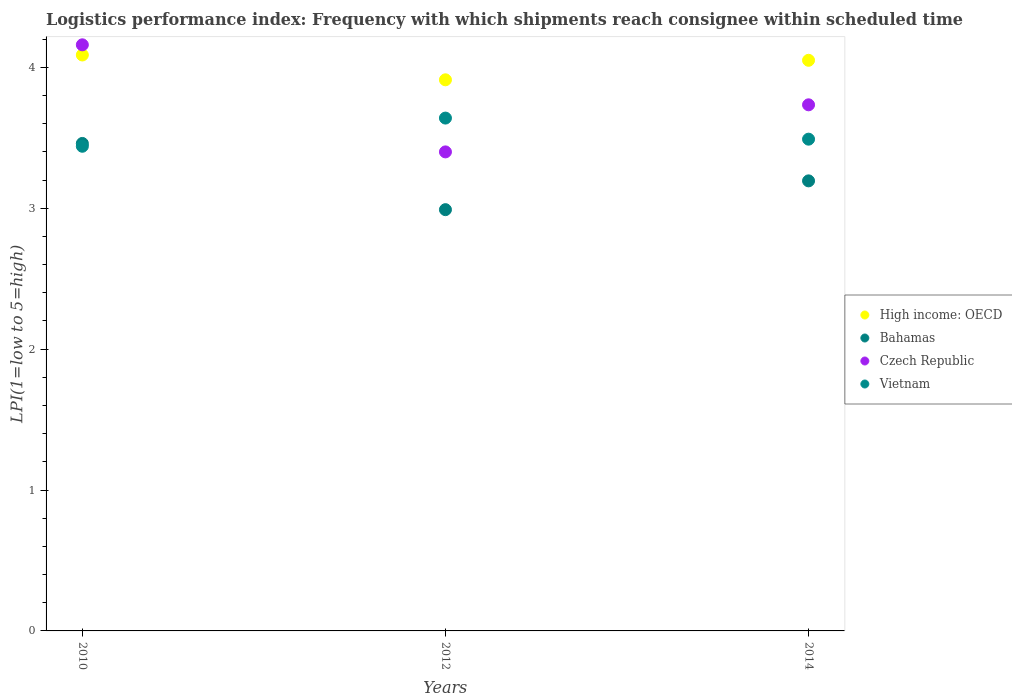Is the number of dotlines equal to the number of legend labels?
Your response must be concise. Yes. What is the logistics performance index in Vietnam in 2014?
Ensure brevity in your answer.  3.49. Across all years, what is the maximum logistics performance index in Bahamas?
Make the answer very short. 3.46. Across all years, what is the minimum logistics performance index in Bahamas?
Your answer should be very brief. 2.99. In which year was the logistics performance index in High income: OECD maximum?
Provide a short and direct response. 2010. In which year was the logistics performance index in Bahamas minimum?
Make the answer very short. 2012. What is the total logistics performance index in Bahamas in the graph?
Provide a succinct answer. 9.64. What is the difference between the logistics performance index in High income: OECD in 2012 and that in 2014?
Your answer should be very brief. -0.14. What is the difference between the logistics performance index in Bahamas in 2012 and the logistics performance index in Czech Republic in 2010?
Your answer should be very brief. -1.17. What is the average logistics performance index in High income: OECD per year?
Make the answer very short. 4.02. In the year 2012, what is the difference between the logistics performance index in High income: OECD and logistics performance index in Bahamas?
Ensure brevity in your answer.  0.92. In how many years, is the logistics performance index in Vietnam greater than 3.6?
Keep it short and to the point. 1. What is the ratio of the logistics performance index in Bahamas in 2010 to that in 2012?
Ensure brevity in your answer.  1.16. What is the difference between the highest and the second highest logistics performance index in Bahamas?
Your answer should be compact. 0.27. What is the difference between the highest and the lowest logistics performance index in Bahamas?
Your response must be concise. 0.47. Is the logistics performance index in Czech Republic strictly greater than the logistics performance index in High income: OECD over the years?
Your response must be concise. No. Is the logistics performance index in Bahamas strictly less than the logistics performance index in High income: OECD over the years?
Your answer should be very brief. Yes. How many dotlines are there?
Ensure brevity in your answer.  4. How many years are there in the graph?
Provide a succinct answer. 3. Where does the legend appear in the graph?
Keep it short and to the point. Center right. How many legend labels are there?
Ensure brevity in your answer.  4. What is the title of the graph?
Keep it short and to the point. Logistics performance index: Frequency with which shipments reach consignee within scheduled time. Does "Thailand" appear as one of the legend labels in the graph?
Your answer should be very brief. No. What is the label or title of the X-axis?
Your answer should be compact. Years. What is the label or title of the Y-axis?
Offer a very short reply. LPI(1=low to 5=high). What is the LPI(1=low to 5=high) in High income: OECD in 2010?
Your answer should be very brief. 4.09. What is the LPI(1=low to 5=high) in Bahamas in 2010?
Provide a succinct answer. 3.46. What is the LPI(1=low to 5=high) of Czech Republic in 2010?
Offer a terse response. 4.16. What is the LPI(1=low to 5=high) of Vietnam in 2010?
Keep it short and to the point. 3.44. What is the LPI(1=low to 5=high) in High income: OECD in 2012?
Make the answer very short. 3.91. What is the LPI(1=low to 5=high) of Bahamas in 2012?
Provide a succinct answer. 2.99. What is the LPI(1=low to 5=high) in Czech Republic in 2012?
Keep it short and to the point. 3.4. What is the LPI(1=low to 5=high) of Vietnam in 2012?
Offer a very short reply. 3.64. What is the LPI(1=low to 5=high) in High income: OECD in 2014?
Make the answer very short. 4.05. What is the LPI(1=low to 5=high) in Bahamas in 2014?
Offer a terse response. 3.19. What is the LPI(1=low to 5=high) in Czech Republic in 2014?
Provide a short and direct response. 3.73. What is the LPI(1=low to 5=high) of Vietnam in 2014?
Offer a very short reply. 3.49. Across all years, what is the maximum LPI(1=low to 5=high) of High income: OECD?
Ensure brevity in your answer.  4.09. Across all years, what is the maximum LPI(1=low to 5=high) in Bahamas?
Keep it short and to the point. 3.46. Across all years, what is the maximum LPI(1=low to 5=high) of Czech Republic?
Provide a short and direct response. 4.16. Across all years, what is the maximum LPI(1=low to 5=high) of Vietnam?
Ensure brevity in your answer.  3.64. Across all years, what is the minimum LPI(1=low to 5=high) in High income: OECD?
Offer a very short reply. 3.91. Across all years, what is the minimum LPI(1=low to 5=high) in Bahamas?
Give a very brief answer. 2.99. Across all years, what is the minimum LPI(1=low to 5=high) of Vietnam?
Offer a very short reply. 3.44. What is the total LPI(1=low to 5=high) of High income: OECD in the graph?
Provide a short and direct response. 12.05. What is the total LPI(1=low to 5=high) in Bahamas in the graph?
Make the answer very short. 9.64. What is the total LPI(1=low to 5=high) in Czech Republic in the graph?
Your answer should be very brief. 11.29. What is the total LPI(1=low to 5=high) of Vietnam in the graph?
Keep it short and to the point. 10.57. What is the difference between the LPI(1=low to 5=high) in High income: OECD in 2010 and that in 2012?
Provide a short and direct response. 0.18. What is the difference between the LPI(1=low to 5=high) of Bahamas in 2010 and that in 2012?
Your response must be concise. 0.47. What is the difference between the LPI(1=low to 5=high) of Czech Republic in 2010 and that in 2012?
Make the answer very short. 0.76. What is the difference between the LPI(1=low to 5=high) of Vietnam in 2010 and that in 2012?
Your answer should be compact. -0.2. What is the difference between the LPI(1=low to 5=high) of High income: OECD in 2010 and that in 2014?
Provide a succinct answer. 0.04. What is the difference between the LPI(1=low to 5=high) of Bahamas in 2010 and that in 2014?
Make the answer very short. 0.27. What is the difference between the LPI(1=low to 5=high) of Czech Republic in 2010 and that in 2014?
Your response must be concise. 0.43. What is the difference between the LPI(1=low to 5=high) in Vietnam in 2010 and that in 2014?
Your response must be concise. -0.05. What is the difference between the LPI(1=low to 5=high) in High income: OECD in 2012 and that in 2014?
Offer a terse response. -0.14. What is the difference between the LPI(1=low to 5=high) of Bahamas in 2012 and that in 2014?
Your answer should be compact. -0.2. What is the difference between the LPI(1=low to 5=high) in Czech Republic in 2012 and that in 2014?
Keep it short and to the point. -0.33. What is the difference between the LPI(1=low to 5=high) in Vietnam in 2012 and that in 2014?
Keep it short and to the point. 0.15. What is the difference between the LPI(1=low to 5=high) in High income: OECD in 2010 and the LPI(1=low to 5=high) in Bahamas in 2012?
Keep it short and to the point. 1.1. What is the difference between the LPI(1=low to 5=high) of High income: OECD in 2010 and the LPI(1=low to 5=high) of Czech Republic in 2012?
Your response must be concise. 0.69. What is the difference between the LPI(1=low to 5=high) in High income: OECD in 2010 and the LPI(1=low to 5=high) in Vietnam in 2012?
Ensure brevity in your answer.  0.45. What is the difference between the LPI(1=low to 5=high) of Bahamas in 2010 and the LPI(1=low to 5=high) of Vietnam in 2012?
Give a very brief answer. -0.18. What is the difference between the LPI(1=low to 5=high) in Czech Republic in 2010 and the LPI(1=low to 5=high) in Vietnam in 2012?
Offer a terse response. 0.52. What is the difference between the LPI(1=low to 5=high) in High income: OECD in 2010 and the LPI(1=low to 5=high) in Bahamas in 2014?
Your response must be concise. 0.89. What is the difference between the LPI(1=low to 5=high) of High income: OECD in 2010 and the LPI(1=low to 5=high) of Czech Republic in 2014?
Your response must be concise. 0.35. What is the difference between the LPI(1=low to 5=high) in High income: OECD in 2010 and the LPI(1=low to 5=high) in Vietnam in 2014?
Provide a short and direct response. 0.6. What is the difference between the LPI(1=low to 5=high) of Bahamas in 2010 and the LPI(1=low to 5=high) of Czech Republic in 2014?
Your answer should be compact. -0.27. What is the difference between the LPI(1=low to 5=high) in Bahamas in 2010 and the LPI(1=low to 5=high) in Vietnam in 2014?
Provide a short and direct response. -0.03. What is the difference between the LPI(1=low to 5=high) of Czech Republic in 2010 and the LPI(1=low to 5=high) of Vietnam in 2014?
Your response must be concise. 0.67. What is the difference between the LPI(1=low to 5=high) in High income: OECD in 2012 and the LPI(1=low to 5=high) in Bahamas in 2014?
Your answer should be compact. 0.72. What is the difference between the LPI(1=low to 5=high) of High income: OECD in 2012 and the LPI(1=low to 5=high) of Czech Republic in 2014?
Provide a succinct answer. 0.18. What is the difference between the LPI(1=low to 5=high) in High income: OECD in 2012 and the LPI(1=low to 5=high) in Vietnam in 2014?
Offer a terse response. 0.42. What is the difference between the LPI(1=low to 5=high) in Bahamas in 2012 and the LPI(1=low to 5=high) in Czech Republic in 2014?
Provide a succinct answer. -0.74. What is the difference between the LPI(1=low to 5=high) of Bahamas in 2012 and the LPI(1=low to 5=high) of Vietnam in 2014?
Your answer should be very brief. -0.5. What is the difference between the LPI(1=low to 5=high) of Czech Republic in 2012 and the LPI(1=low to 5=high) of Vietnam in 2014?
Provide a short and direct response. -0.09. What is the average LPI(1=low to 5=high) of High income: OECD per year?
Keep it short and to the point. 4.02. What is the average LPI(1=low to 5=high) in Bahamas per year?
Ensure brevity in your answer.  3.21. What is the average LPI(1=low to 5=high) of Czech Republic per year?
Your response must be concise. 3.76. What is the average LPI(1=low to 5=high) in Vietnam per year?
Make the answer very short. 3.52. In the year 2010, what is the difference between the LPI(1=low to 5=high) in High income: OECD and LPI(1=low to 5=high) in Bahamas?
Your answer should be very brief. 0.63. In the year 2010, what is the difference between the LPI(1=low to 5=high) of High income: OECD and LPI(1=low to 5=high) of Czech Republic?
Provide a succinct answer. -0.07. In the year 2010, what is the difference between the LPI(1=low to 5=high) of High income: OECD and LPI(1=low to 5=high) of Vietnam?
Make the answer very short. 0.65. In the year 2010, what is the difference between the LPI(1=low to 5=high) of Czech Republic and LPI(1=low to 5=high) of Vietnam?
Your answer should be very brief. 0.72. In the year 2012, what is the difference between the LPI(1=low to 5=high) of High income: OECD and LPI(1=low to 5=high) of Bahamas?
Keep it short and to the point. 0.92. In the year 2012, what is the difference between the LPI(1=low to 5=high) of High income: OECD and LPI(1=low to 5=high) of Czech Republic?
Ensure brevity in your answer.  0.51. In the year 2012, what is the difference between the LPI(1=low to 5=high) of High income: OECD and LPI(1=low to 5=high) of Vietnam?
Offer a terse response. 0.27. In the year 2012, what is the difference between the LPI(1=low to 5=high) in Bahamas and LPI(1=low to 5=high) in Czech Republic?
Keep it short and to the point. -0.41. In the year 2012, what is the difference between the LPI(1=low to 5=high) of Bahamas and LPI(1=low to 5=high) of Vietnam?
Give a very brief answer. -0.65. In the year 2012, what is the difference between the LPI(1=low to 5=high) of Czech Republic and LPI(1=low to 5=high) of Vietnam?
Make the answer very short. -0.24. In the year 2014, what is the difference between the LPI(1=low to 5=high) in High income: OECD and LPI(1=low to 5=high) in Bahamas?
Provide a short and direct response. 0.86. In the year 2014, what is the difference between the LPI(1=low to 5=high) in High income: OECD and LPI(1=low to 5=high) in Czech Republic?
Your response must be concise. 0.32. In the year 2014, what is the difference between the LPI(1=low to 5=high) in High income: OECD and LPI(1=low to 5=high) in Vietnam?
Your response must be concise. 0.56. In the year 2014, what is the difference between the LPI(1=low to 5=high) of Bahamas and LPI(1=low to 5=high) of Czech Republic?
Offer a terse response. -0.54. In the year 2014, what is the difference between the LPI(1=low to 5=high) in Bahamas and LPI(1=low to 5=high) in Vietnam?
Make the answer very short. -0.3. In the year 2014, what is the difference between the LPI(1=low to 5=high) of Czech Republic and LPI(1=low to 5=high) of Vietnam?
Offer a terse response. 0.24. What is the ratio of the LPI(1=low to 5=high) in High income: OECD in 2010 to that in 2012?
Offer a very short reply. 1.04. What is the ratio of the LPI(1=low to 5=high) of Bahamas in 2010 to that in 2012?
Give a very brief answer. 1.16. What is the ratio of the LPI(1=low to 5=high) of Czech Republic in 2010 to that in 2012?
Keep it short and to the point. 1.22. What is the ratio of the LPI(1=low to 5=high) of Vietnam in 2010 to that in 2012?
Ensure brevity in your answer.  0.95. What is the ratio of the LPI(1=low to 5=high) in High income: OECD in 2010 to that in 2014?
Give a very brief answer. 1.01. What is the ratio of the LPI(1=low to 5=high) in Bahamas in 2010 to that in 2014?
Give a very brief answer. 1.08. What is the ratio of the LPI(1=low to 5=high) of Czech Republic in 2010 to that in 2014?
Keep it short and to the point. 1.11. What is the ratio of the LPI(1=low to 5=high) in Vietnam in 2010 to that in 2014?
Your response must be concise. 0.99. What is the ratio of the LPI(1=low to 5=high) in High income: OECD in 2012 to that in 2014?
Offer a very short reply. 0.97. What is the ratio of the LPI(1=low to 5=high) in Bahamas in 2012 to that in 2014?
Give a very brief answer. 0.94. What is the ratio of the LPI(1=low to 5=high) in Czech Republic in 2012 to that in 2014?
Your answer should be very brief. 0.91. What is the ratio of the LPI(1=low to 5=high) of Vietnam in 2012 to that in 2014?
Your answer should be compact. 1.04. What is the difference between the highest and the second highest LPI(1=low to 5=high) of High income: OECD?
Your answer should be very brief. 0.04. What is the difference between the highest and the second highest LPI(1=low to 5=high) in Bahamas?
Your answer should be compact. 0.27. What is the difference between the highest and the second highest LPI(1=low to 5=high) of Czech Republic?
Keep it short and to the point. 0.43. What is the difference between the highest and the second highest LPI(1=low to 5=high) in Vietnam?
Your response must be concise. 0.15. What is the difference between the highest and the lowest LPI(1=low to 5=high) in High income: OECD?
Your answer should be compact. 0.18. What is the difference between the highest and the lowest LPI(1=low to 5=high) of Bahamas?
Your response must be concise. 0.47. What is the difference between the highest and the lowest LPI(1=low to 5=high) in Czech Republic?
Ensure brevity in your answer.  0.76. 